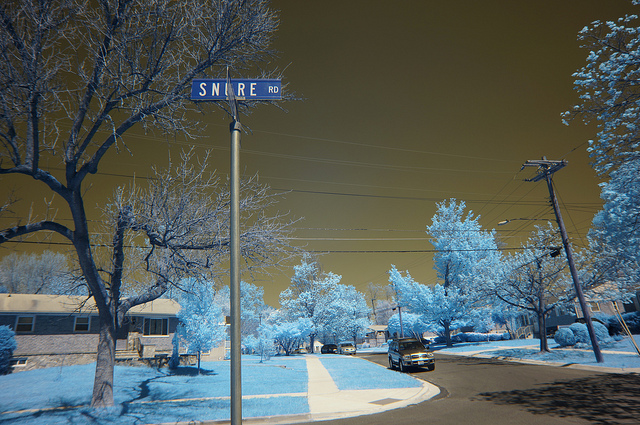Identify the text displayed in this image. SNIRE RD 